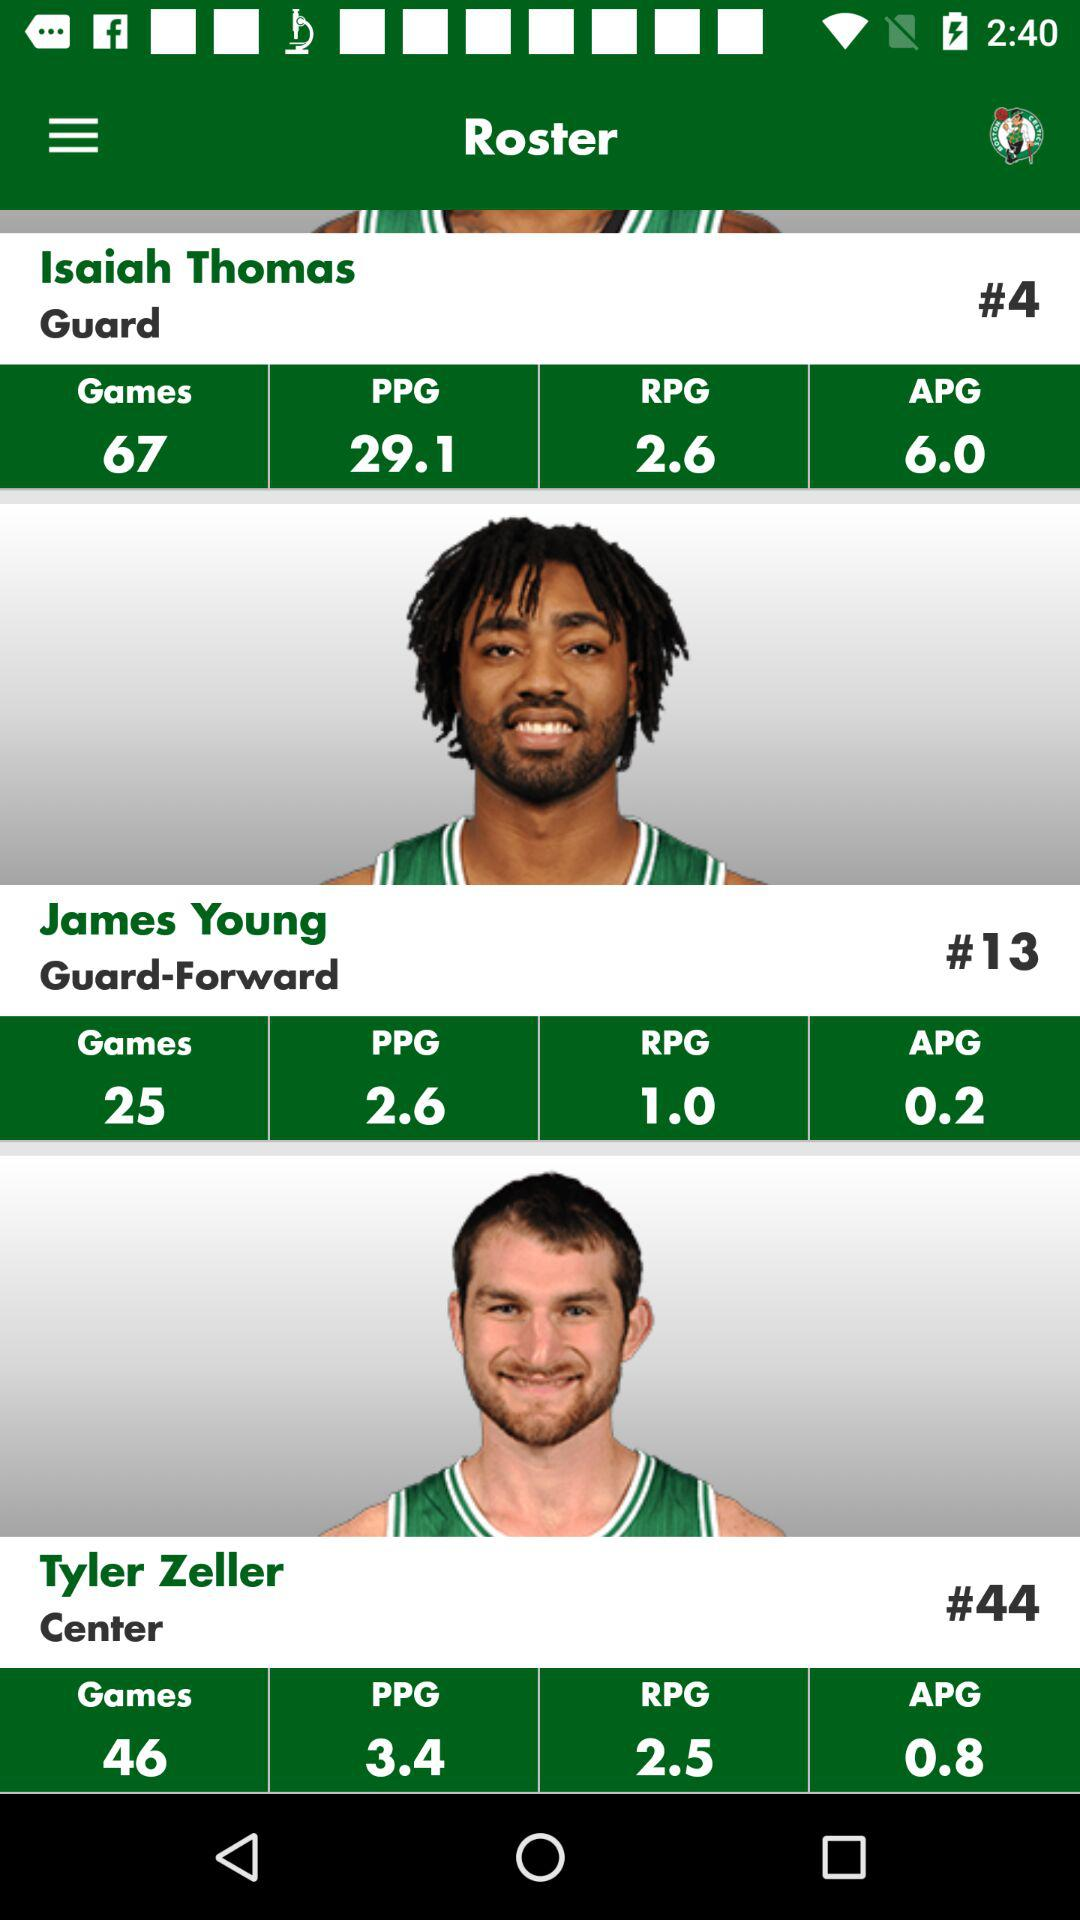What is the position at which Tyler Zeller plays? Tyler Zeller plays at Center. 